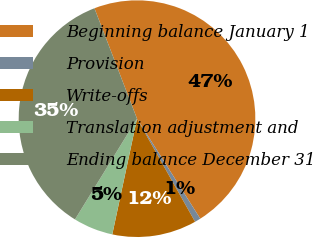Convert chart to OTSL. <chart><loc_0><loc_0><loc_500><loc_500><pie_chart><fcel>Beginning balance January 1<fcel>Provision<fcel>Write-offs<fcel>Translation adjustment and<fcel>Ending balance December 31<nl><fcel>46.88%<fcel>0.82%<fcel>11.51%<fcel>5.43%<fcel>35.36%<nl></chart> 